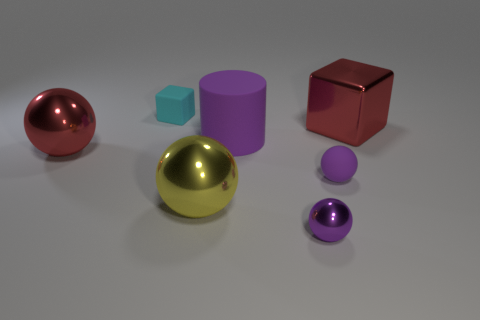There is a cyan matte thing; does it have the same size as the shiny object in front of the yellow thing?
Your answer should be very brief. Yes. There is a small purple object that is to the right of the purple metallic thing; what is its shape?
Your answer should be compact. Sphere. Are there any tiny cubes to the right of the block in front of the small rubber thing to the left of the big matte thing?
Your answer should be very brief. No. What is the material of the big red object that is the same shape as the small purple matte object?
Give a very brief answer. Metal. Is there anything else that has the same material as the yellow thing?
Provide a succinct answer. Yes. How many cylinders are either cyan objects or large rubber things?
Make the answer very short. 1. There is a cube that is to the left of the red cube; does it have the same size as the cube right of the tiny cyan matte object?
Provide a succinct answer. No. What is the big red object left of the matte ball that is in front of the cyan cube made of?
Provide a short and direct response. Metal. Is the number of red metal blocks that are behind the red sphere less than the number of matte cubes?
Provide a succinct answer. No. What is the shape of the red thing that is the same material as the large red ball?
Offer a very short reply. Cube. 